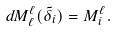Convert formula to latex. <formula><loc_0><loc_0><loc_500><loc_500>d M _ { \ell } ^ { \ell } ( \tilde { \delta } _ { i } ) = M ^ { \ell } _ { i } .</formula> 